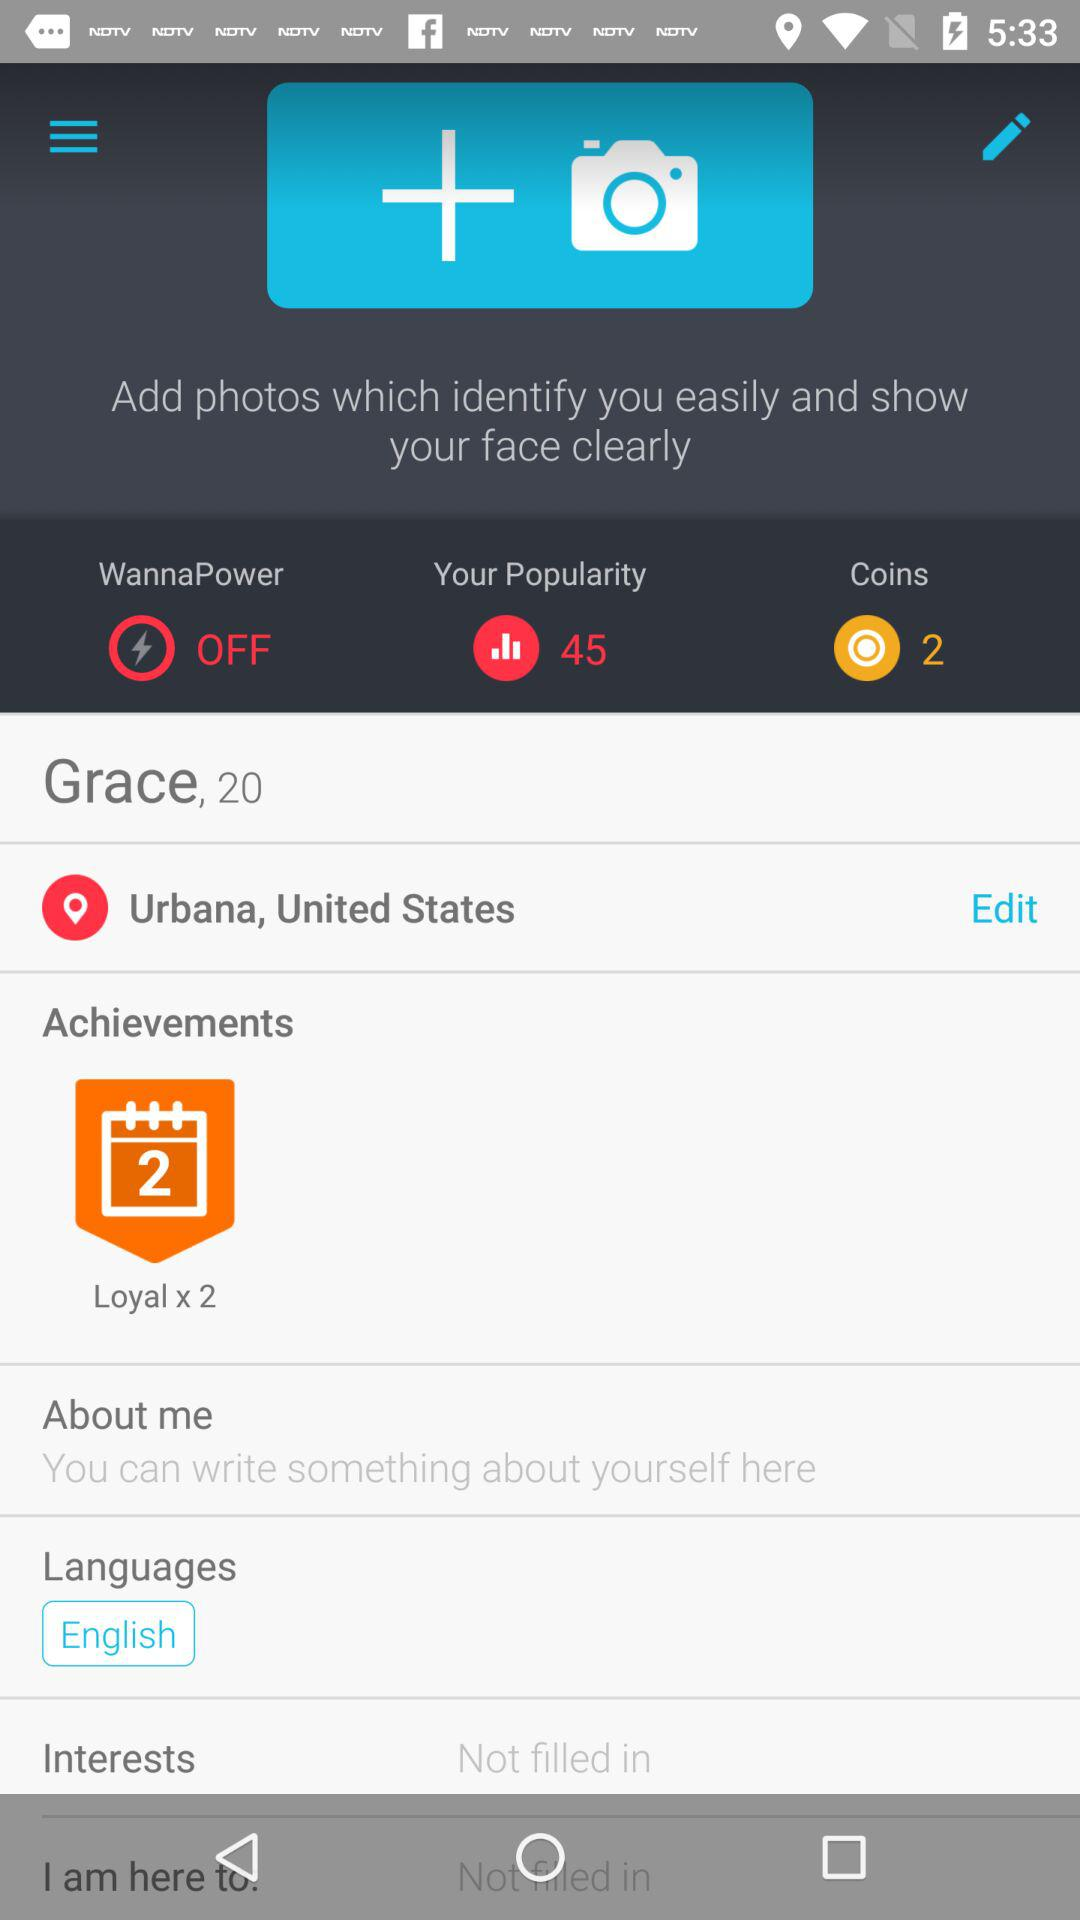What is the age of the user? The user is twenty years old. 